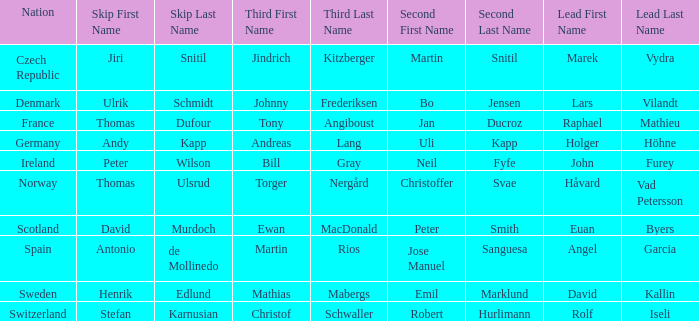Which Skip has a Third of tony angiboust? Thomas Dufour. 